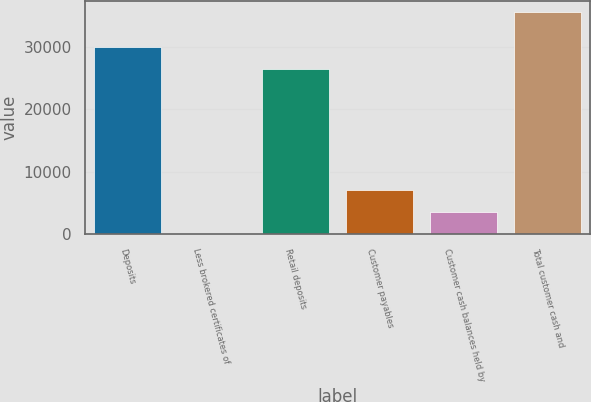Convert chart. <chart><loc_0><loc_0><loc_500><loc_500><bar_chart><fcel>Deposits<fcel>Less brokered certificates of<fcel>Retail deposits<fcel>Customer payables<fcel>Customer cash balances held by<fcel>Total customer cash and<nl><fcel>29977.3<fcel>33.2<fcel>26426.8<fcel>7134.12<fcel>3583.66<fcel>35537.8<nl></chart> 